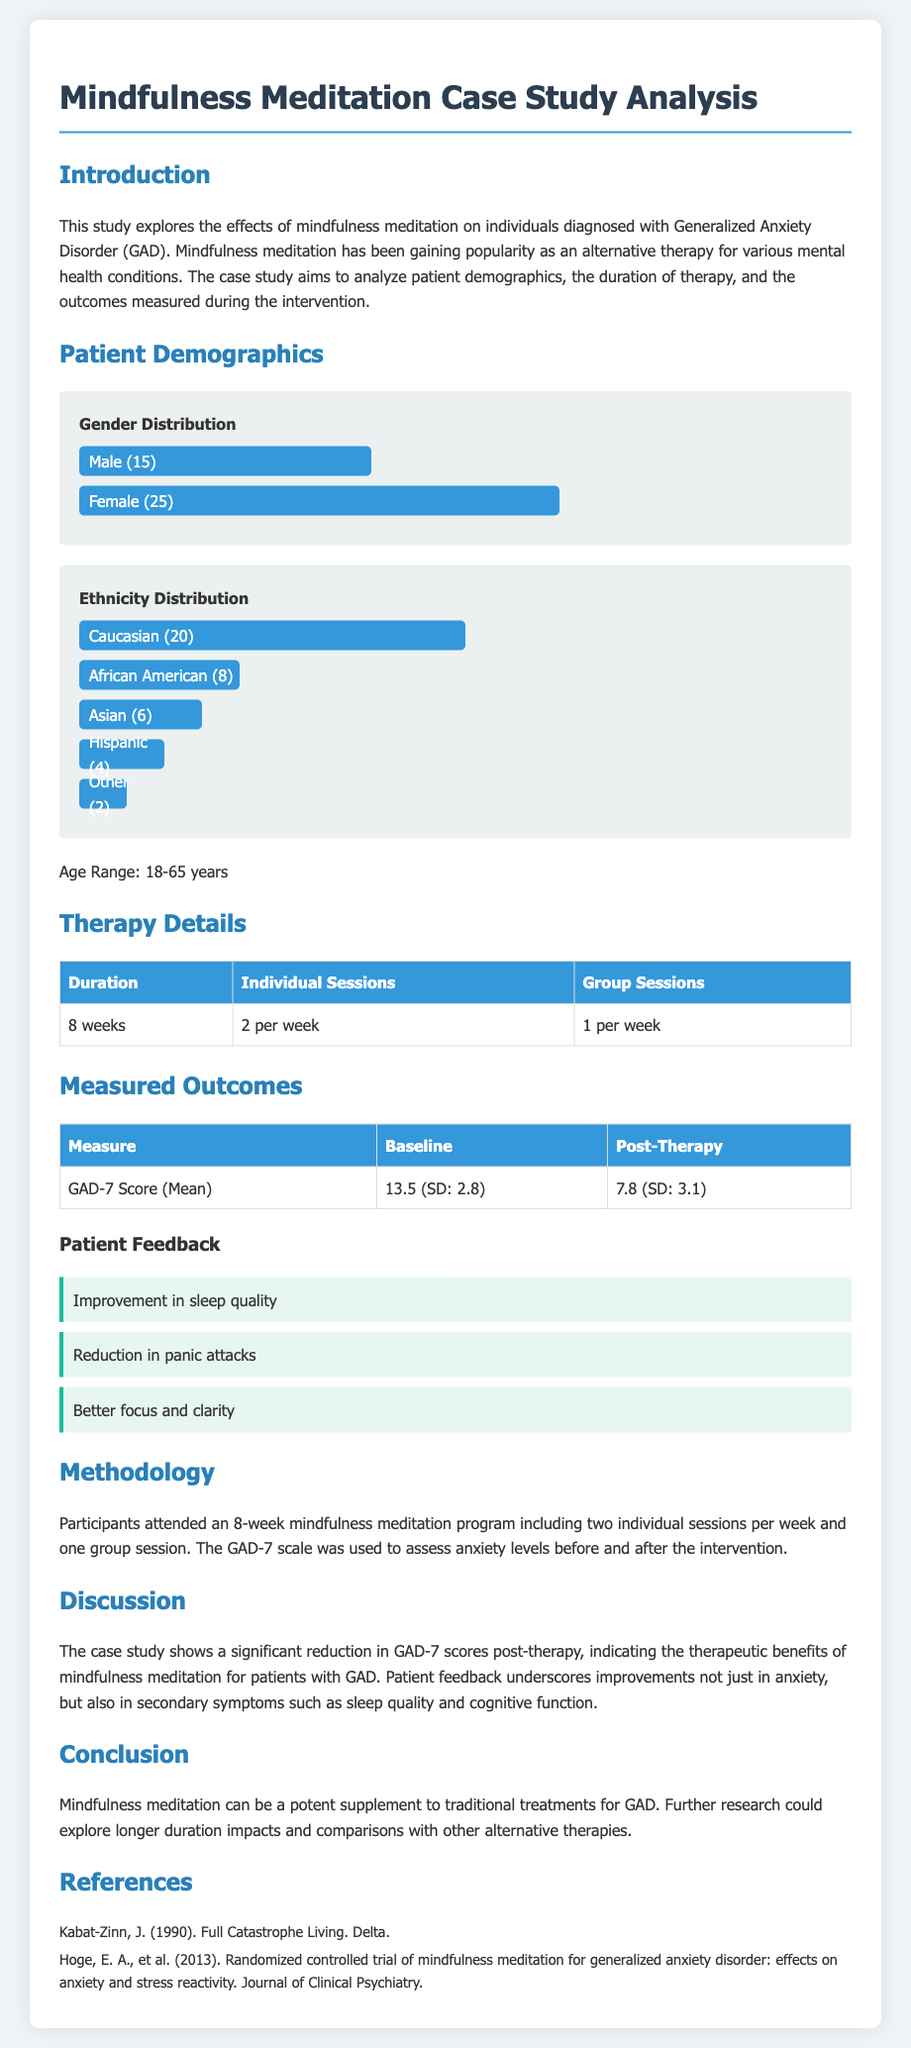What is the gender distribution of patients? Male patients make up 37.5% and female patients make up 62.5% of the total, indicating a higher representation of females.
Answer: Male (15), Female (25) What is the age range of participants in the study? The document states that participants' ages range from 18 to 65 years.
Answer: 18-65 years How many individual sessions did each participant attend? Each participant attended two individual sessions per week for eight weeks, totaling 16 individual sessions.
Answer: 16 What was the mean GAD-7 score at baseline? The baseline mean GAD-7 score provided in the document is 13.5.
Answer: 13.5 What improvement was reported by patients regarding sleep? Patients noted an "improvement in sleep quality" as part of their feedback after the intervention.
Answer: Improvement in sleep quality What is the total number of patients involved in the study? The total number of patients can be calculated from the gender distribution, adding 15 males and 25 females, totaling 40 patients.
Answer: 40 What is the focus of the therapy in this case study? The therapy focuses on mindfulness meditation as an alternative treatment for generalized anxiety disorder.
Answer: Mindfulness meditation How long was the duration of the therapy? The therapy lasted for a duration of eight weeks according to the therapy details.
Answer: 8 weeks 